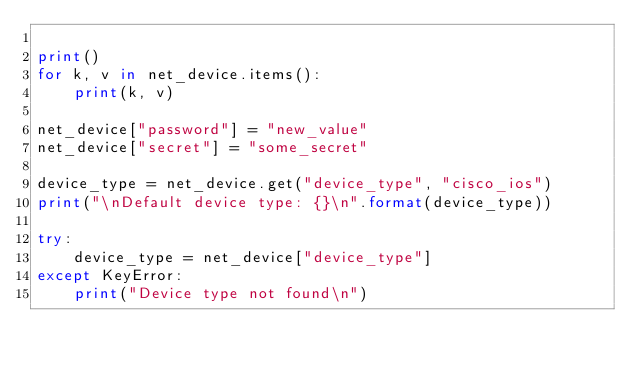Convert code to text. <code><loc_0><loc_0><loc_500><loc_500><_Python_>
print()
for k, v in net_device.items():
    print(k, v)

net_device["password"] = "new_value"
net_device["secret"] = "some_secret"

device_type = net_device.get("device_type", "cisco_ios")
print("\nDefault device type: {}\n".format(device_type))

try:
    device_type = net_device["device_type"]
except KeyError:
    print("Device type not found\n")
</code> 